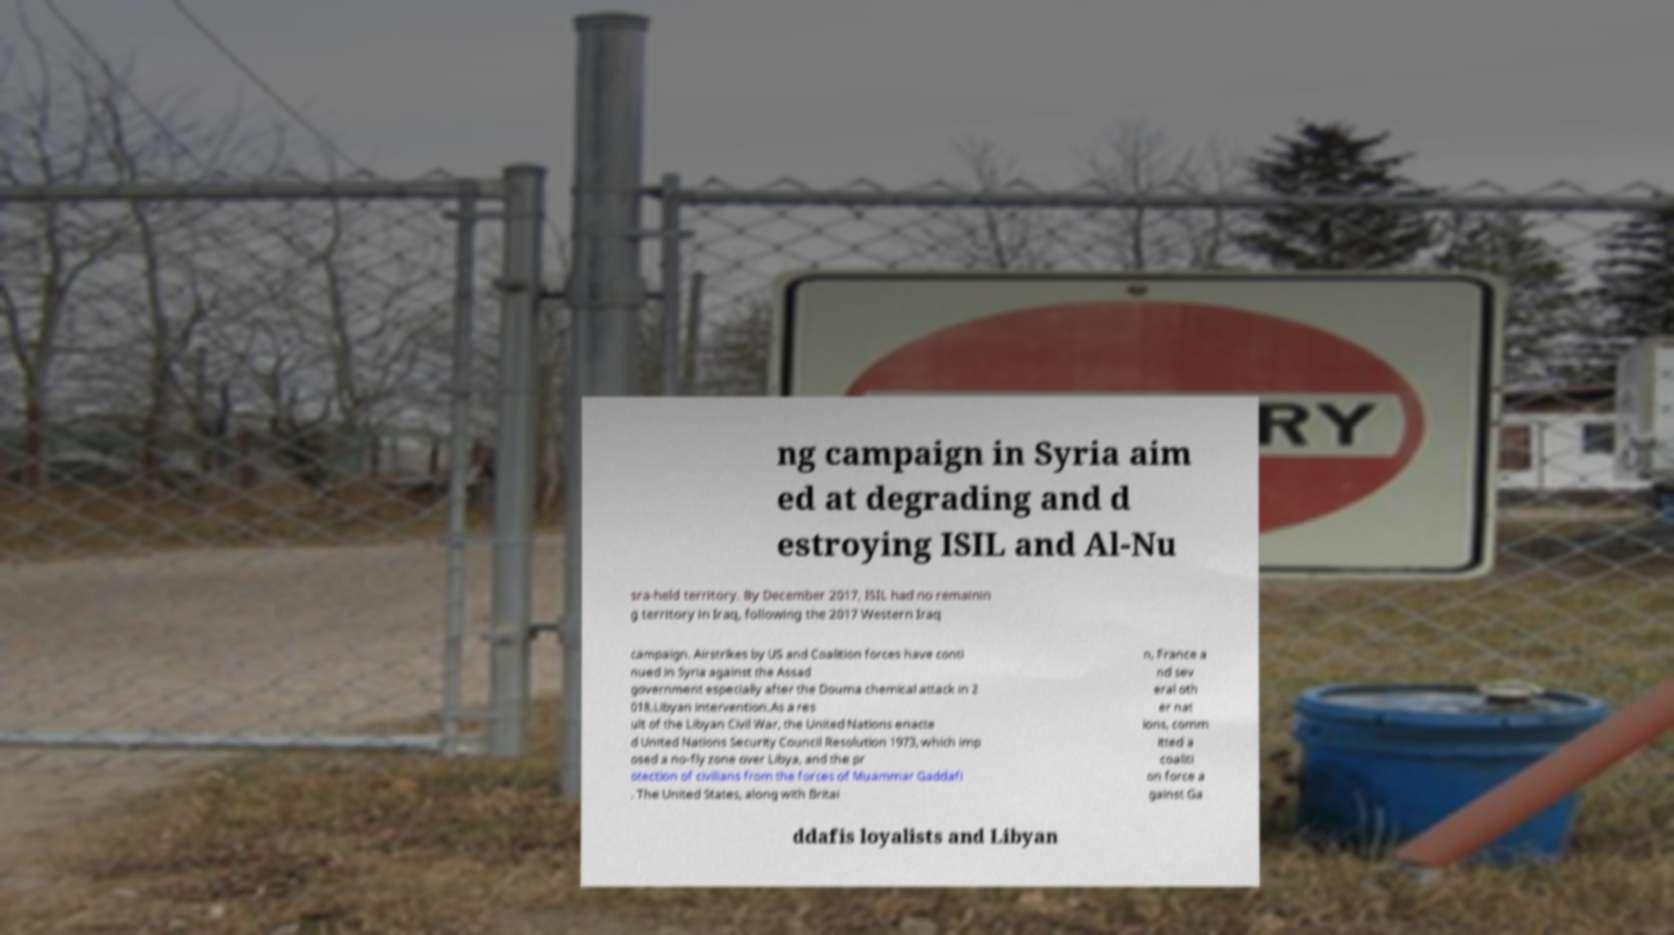Can you accurately transcribe the text from the provided image for me? ng campaign in Syria aim ed at degrading and d estroying ISIL and Al-Nu sra-held territory. By December 2017, ISIL had no remainin g territory in Iraq, following the 2017 Western Iraq campaign. Airstrikes by US and Coalition forces have conti nued in Syria against the Assad government especially after the Douma chemical attack in 2 018.Libyan intervention.As a res ult of the Libyan Civil War, the United Nations enacte d United Nations Security Council Resolution 1973, which imp osed a no-fly zone over Libya, and the pr otection of civilians from the forces of Muammar Gaddafi . The United States, along with Britai n, France a nd sev eral oth er nat ions, comm itted a coaliti on force a gainst Ga ddafis loyalists and Libyan 